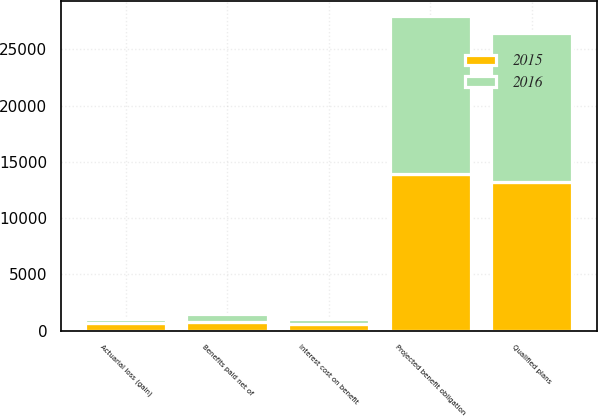<chart> <loc_0><loc_0><loc_500><loc_500><stacked_bar_chart><ecel><fcel>Projected benefit obligation<fcel>Interest cost on benefit<fcel>Actuarial loss (gain)<fcel>Benefits paid net of<fcel>Qualified plans<nl><fcel>2016<fcel>14000<fcel>520<fcel>351<fcel>722<fcel>13271<nl><fcel>2015<fcel>13943<fcel>553<fcel>649<fcel>751<fcel>13231<nl></chart> 